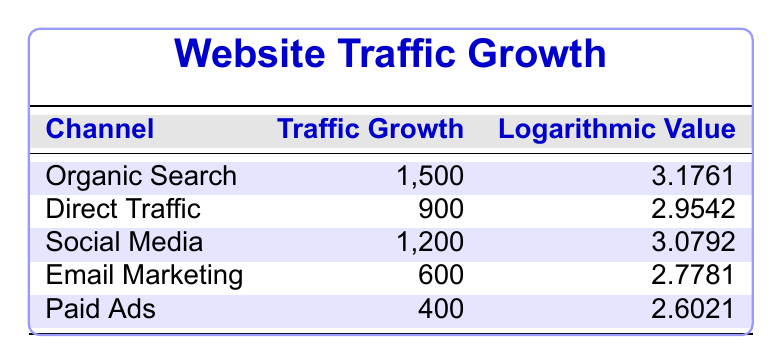What is the traffic growth for Organic Search? According to the table, the traffic growth for Organic Search is specifically listed as 1,500.
Answer: 1,500 Which channel has the highest logarithmic value? By examining the logarithmic values for each channel, Organic Search has the highest value at 3.1761.
Answer: Organic Search What is the logarithmic value for Paid Ads? The table shows the logarithmic value for Paid Ads as 2.6021.
Answer: 2.6021 What is the combined traffic growth for Social Media and Email Marketing? The traffic growth for Social Media is 1,200 and for Email Marketing is 600. Combining these gives 1,200 + 600 = 1,800.
Answer: 1,800 Is the traffic growth for Direct Traffic greater than that for Email Marketing? Direct Traffic has a growth of 900, while Email Marketing has a growth of 600. Since 900 is greater than 600, the answer is yes.
Answer: Yes Which channel's traffic growth is below 800? Reviewing the traffic growth numbers, only the Paid Ads channel, with a growth of 400, is below 800.
Answer: Paid Ads What is the average traffic growth across all channels? The total traffic growth can be calculated: 1,500 + 900 + 1,200 + 600 + 400 = 4,600. There are 5 channels, so the average is 4,600 / 5 = 920.
Answer: 920 How many channels have a logarithmic value higher than 3? Looking at the table, two channels have logarithmic values higher than 3: Organic Search (3.1761) and Social Media (3.0792), so the count is 2.
Answer: 2 Does the traffic growth for Email Marketing exceed that for Paid Ads? Email Marketing has a growth of 600, whereas Paid Ads has a growth of 400. Since 600 is greater than 400, the answer is yes.
Answer: Yes 